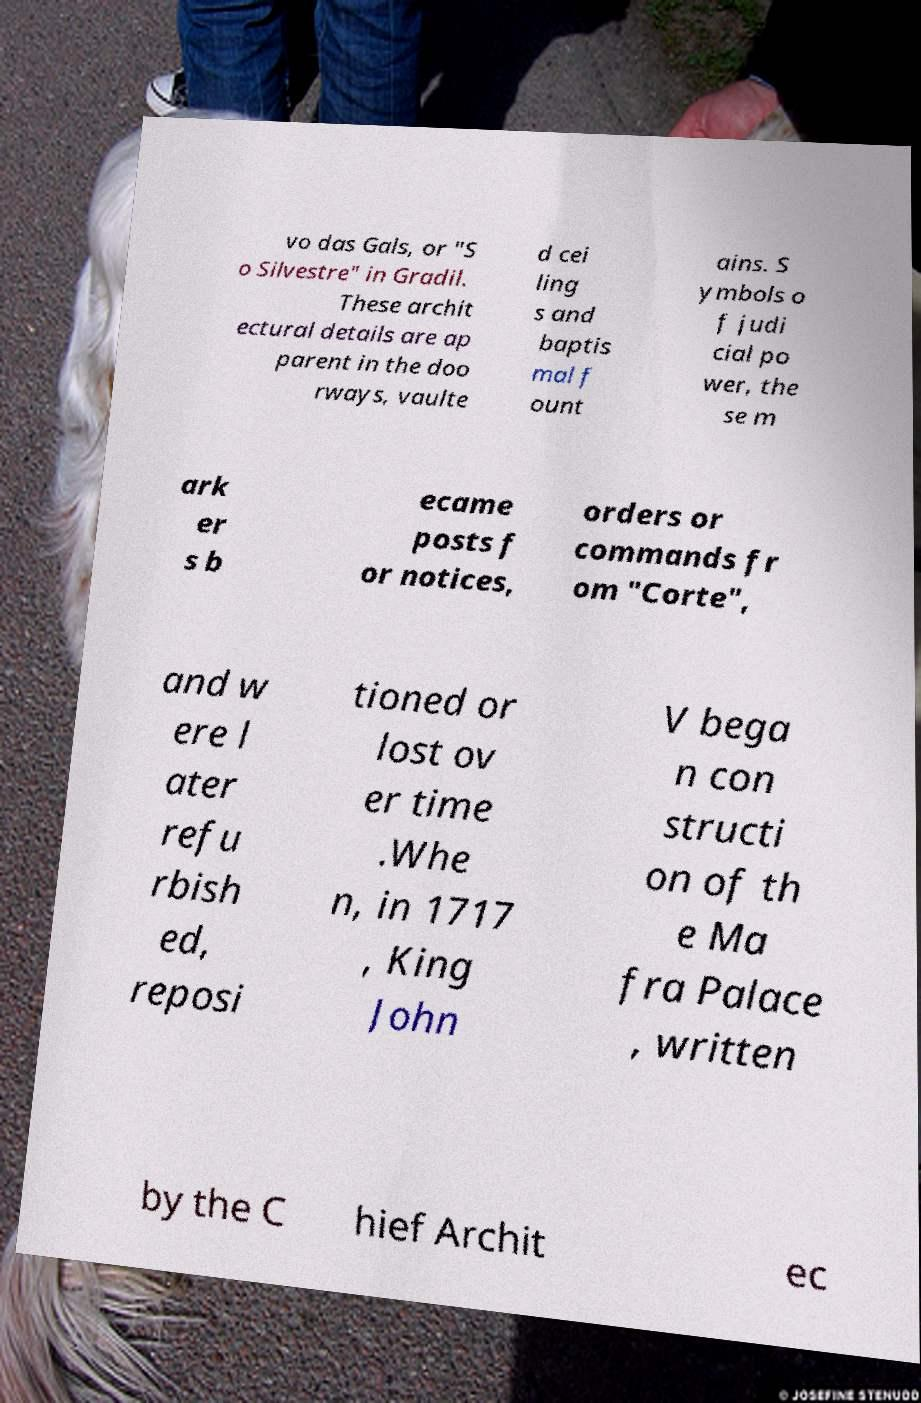There's text embedded in this image that I need extracted. Can you transcribe it verbatim? vo das Gals, or "S o Silvestre" in Gradil. These archit ectural details are ap parent in the doo rways, vaulte d cei ling s and baptis mal f ount ains. S ymbols o f judi cial po wer, the se m ark er s b ecame posts f or notices, orders or commands fr om "Corte", and w ere l ater refu rbish ed, reposi tioned or lost ov er time .Whe n, in 1717 , King John V bega n con structi on of th e Ma fra Palace , written by the C hief Archit ec 